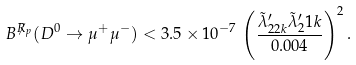Convert formula to latex. <formula><loc_0><loc_0><loc_500><loc_500>B ^ { \not R _ { p } } ( D ^ { 0 } \to \mu ^ { + } \mu ^ { - } ) < 3 . 5 \times 1 0 ^ { - 7 } \, \left ( \frac { \tilde { \lambda } ^ { \prime } _ { 2 2 k } \tilde { \lambda } ^ { \prime } _ { 2 } 1 k } { 0 . 0 0 4 } \right ) ^ { 2 } .</formula> 